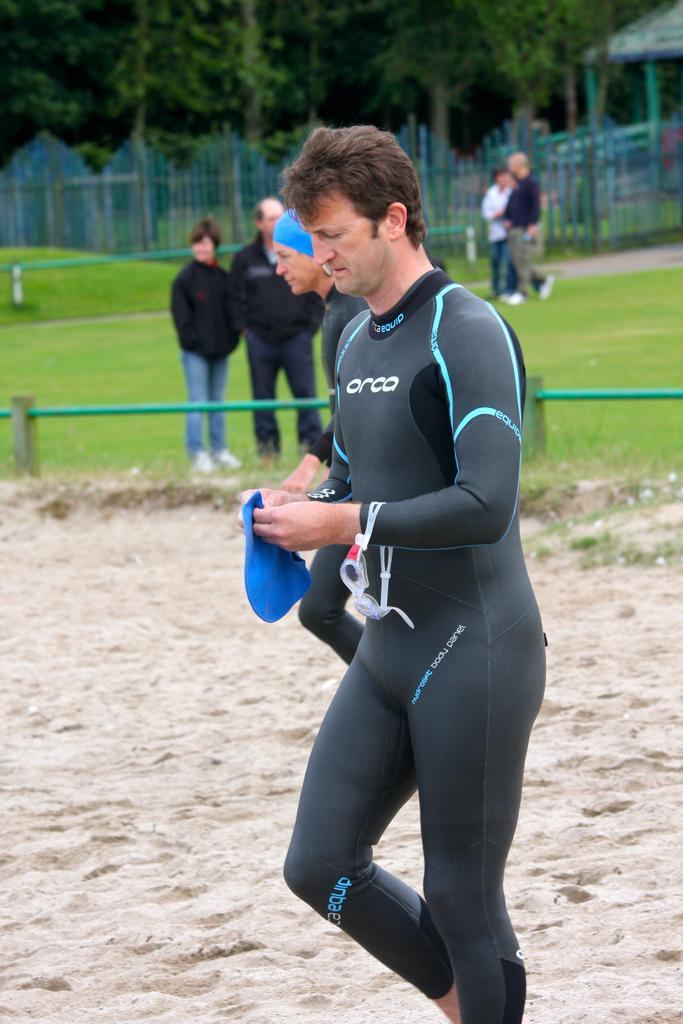Could you give a brief overview of what you see in this image? In the center of the image we can see a man walking and holding an object. in the background there are people and we can see a fence. There are trees. On the right there is a shed. 